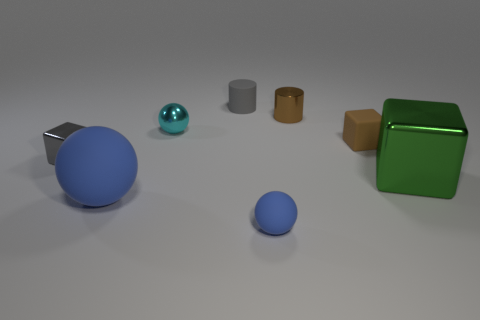Is the number of tiny gray things greater than the number of small brown cubes?
Offer a very short reply. Yes. What is the size of the gray thing that is in front of the tiny gray cylinder that is on the right side of the big ball?
Keep it short and to the point. Small. There is another small thing that is the same shape as the cyan metallic thing; what is its color?
Your answer should be very brief. Blue. What is the size of the metallic sphere?
Your answer should be very brief. Small. What number of cylinders are brown things or small blue things?
Your answer should be compact. 1. There is a gray metal thing that is the same shape as the green metal object; what size is it?
Your answer should be very brief. Small. What number of tiny gray rubber blocks are there?
Provide a succinct answer. 0. There is a large green metal object; does it have the same shape as the tiny shiny object that is on the right side of the cyan metallic sphere?
Keep it short and to the point. No. What is the size of the brown shiny cylinder that is right of the small gray shiny object?
Your response must be concise. Small. What is the material of the tiny cyan object?
Provide a succinct answer. Metal. 